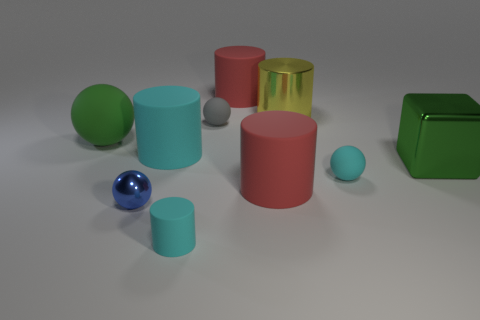Subtract all yellow cylinders. How many cylinders are left? 4 Subtract all yellow metallic cylinders. How many cylinders are left? 4 Subtract 1 balls. How many balls are left? 3 Subtract all brown balls. Subtract all gray cylinders. How many balls are left? 4 Subtract all cubes. How many objects are left? 9 Add 4 metallic blocks. How many metallic blocks are left? 5 Add 2 tiny gray matte things. How many tiny gray matte things exist? 3 Subtract 1 gray spheres. How many objects are left? 9 Subtract all tiny gray objects. Subtract all big red cylinders. How many objects are left? 7 